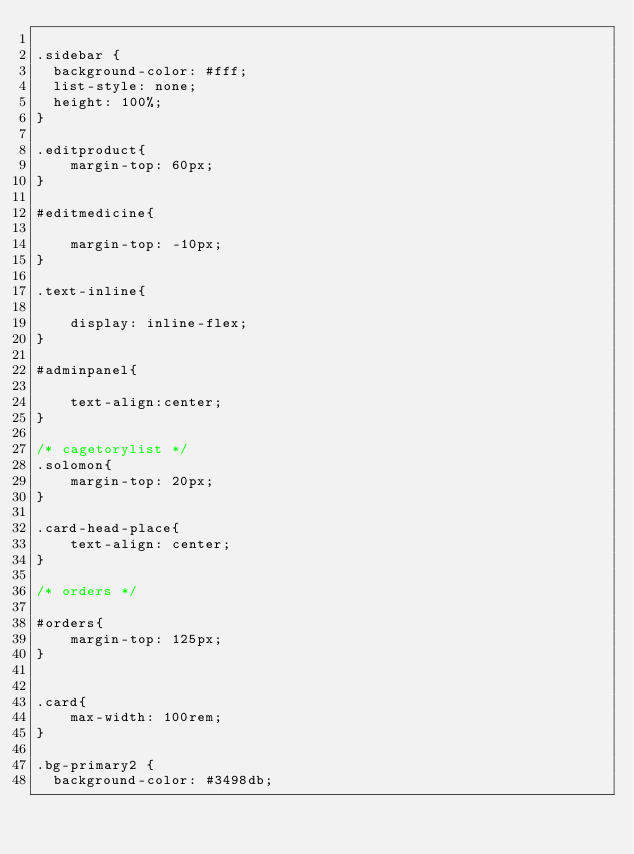Convert code to text. <code><loc_0><loc_0><loc_500><loc_500><_CSS_>
.sidebar {
	background-color: #fff;
	list-style: none;
	height: 100%;
}

.editproduct{
    margin-top: 60px;
}

#editmedicine{

    margin-top: -10px;
}

.text-inline{

    display: inline-flex;
}

#adminpanel{

    text-align:center;
}

/* cagetorylist */
.solomon{
    margin-top: 20px;
}

.card-head-place{
    text-align: center;
}

/* orders */

#orders{
    margin-top: 125px;
}


.card{
    max-width: 100rem;
}

.bg-primary2 {
  background-color: #3498db;</code> 